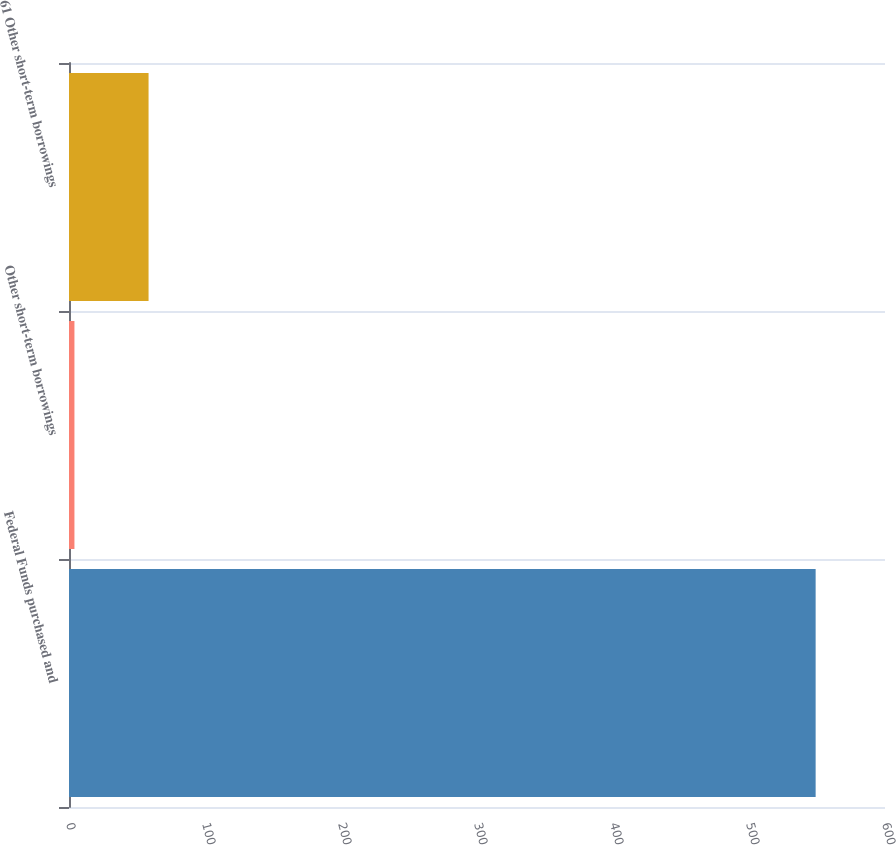Convert chart. <chart><loc_0><loc_0><loc_500><loc_500><bar_chart><fcel>Federal Funds purchased and<fcel>Other short-term borrowings<fcel>61 Other short-term borrowings<nl><fcel>549<fcel>4<fcel>58.5<nl></chart> 